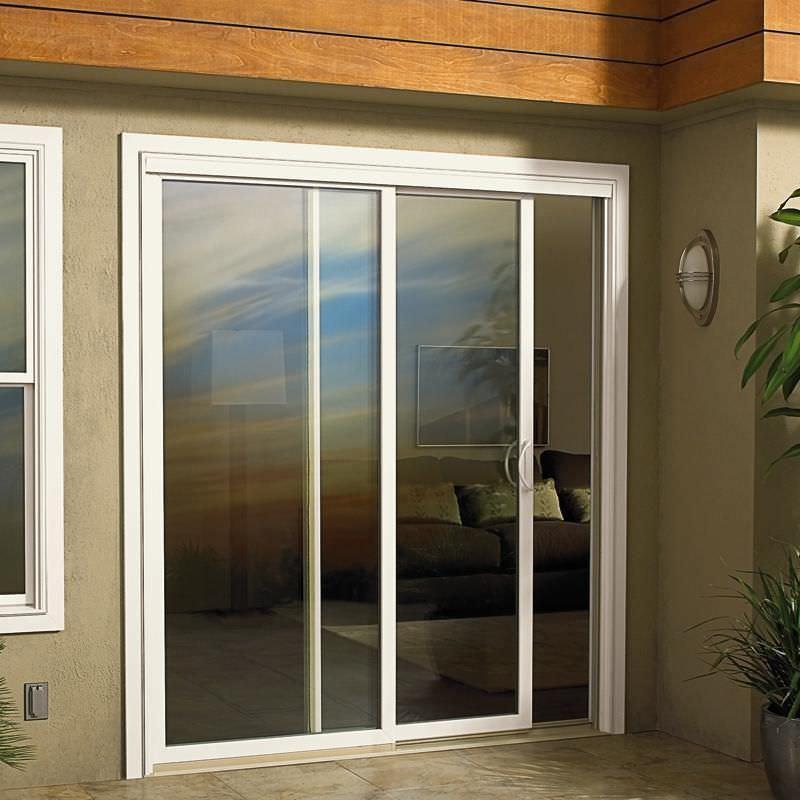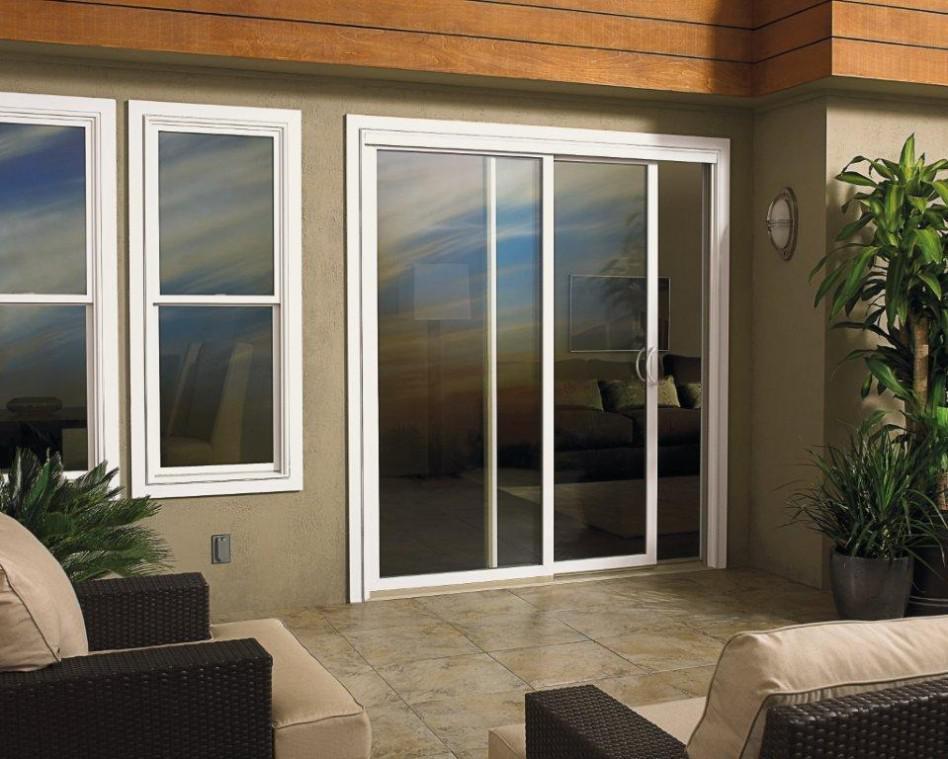The first image is the image on the left, the second image is the image on the right. Considering the images on both sides, is "Right and left images show the same sliding glass door in the same setting." valid? Answer yes or no. Yes. The first image is the image on the left, the second image is the image on the right. Examine the images to the left and right. Is the description "The frame in each image is white." accurate? Answer yes or no. Yes. 